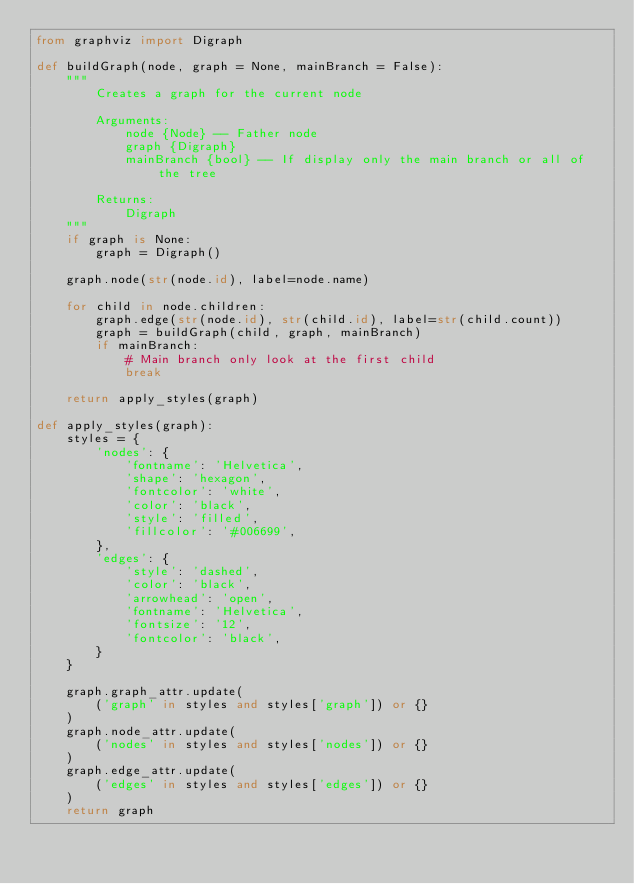Convert code to text. <code><loc_0><loc_0><loc_500><loc_500><_Python_>from graphviz import Digraph

def buildGraph(node, graph = None, mainBranch = False):
    """
        Creates a graph for the current node
    
        Arguments:
            node {Node} -- Father node
            graph {Digraph}
            mainBranch {bool} -- If display only the main branch or all of the tree

        Returns:
            Digraph
    """
    if graph is None:
        graph = Digraph()

    graph.node(str(node.id), label=node.name)

    for child in node.children:
        graph.edge(str(node.id), str(child.id), label=str(child.count))
        graph = buildGraph(child, graph, mainBranch)
        if mainBranch:
            # Main branch only look at the first child
            break

    return apply_styles(graph)

def apply_styles(graph):
    styles = {
        'nodes': {
            'fontname': 'Helvetica',
            'shape': 'hexagon',
            'fontcolor': 'white',
            'color': 'black',
            'style': 'filled',
            'fillcolor': '#006699',
        },
        'edges': {
            'style': 'dashed',
            'color': 'black',
            'arrowhead': 'open',
            'fontname': 'Helvetica',
            'fontsize': '12',
            'fontcolor': 'black',
        }
    }

    graph.graph_attr.update(
        ('graph' in styles and styles['graph']) or {}
    )
    graph.node_attr.update(
        ('nodes' in styles and styles['nodes']) or {}
    )
    graph.edge_attr.update(
        ('edges' in styles and styles['edges']) or {}
    )
    return graph</code> 